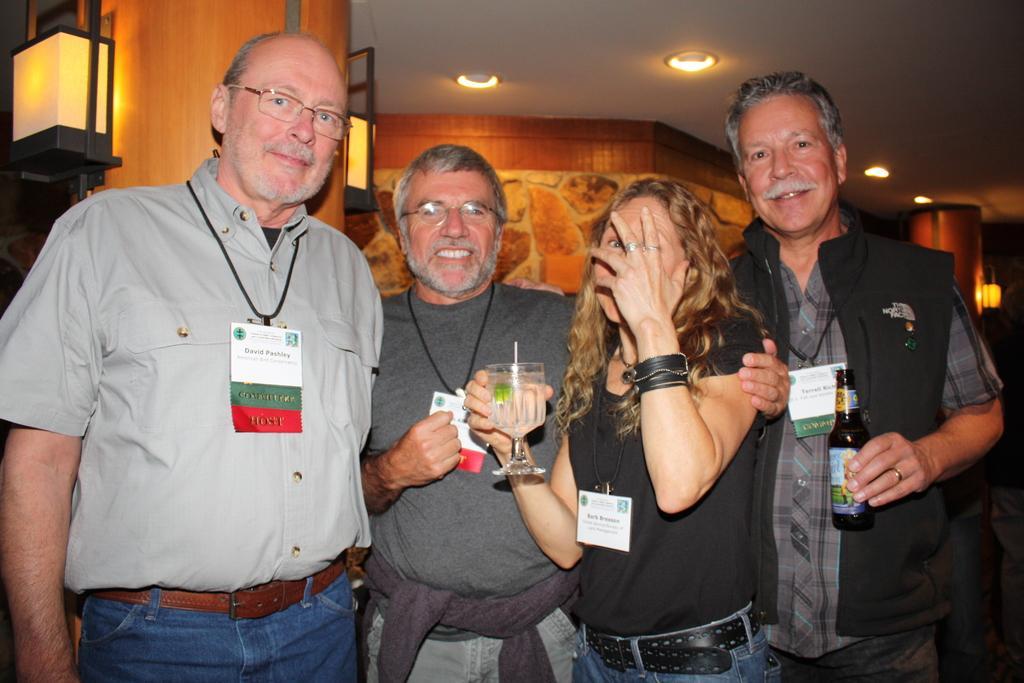In one or two sentences, can you explain what this image depicts? In this picture we can see four persons are standing and wearing id cards and a lady is holding a glass with straw and a man is holding a bottle. In the background of the image we can see the wall, pillars, lights. At the top of the image we can see the roof and lights. 